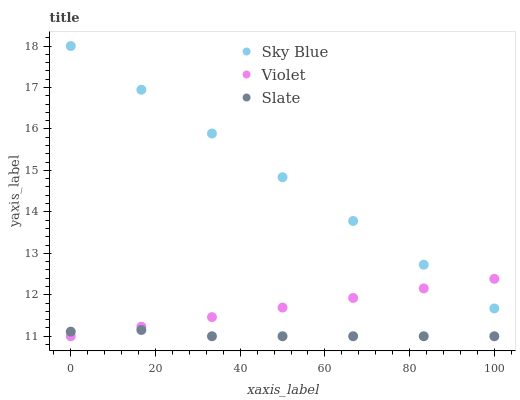Does Slate have the minimum area under the curve?
Answer yes or no. Yes. Does Sky Blue have the maximum area under the curve?
Answer yes or no. Yes. Does Violet have the minimum area under the curve?
Answer yes or no. No. Does Violet have the maximum area under the curve?
Answer yes or no. No. Is Sky Blue the smoothest?
Answer yes or no. Yes. Is Slate the roughest?
Answer yes or no. Yes. Is Violet the smoothest?
Answer yes or no. No. Is Violet the roughest?
Answer yes or no. No. Does Slate have the lowest value?
Answer yes or no. Yes. Does Sky Blue have the highest value?
Answer yes or no. Yes. Does Violet have the highest value?
Answer yes or no. No. Is Slate less than Sky Blue?
Answer yes or no. Yes. Is Sky Blue greater than Slate?
Answer yes or no. Yes. Does Sky Blue intersect Violet?
Answer yes or no. Yes. Is Sky Blue less than Violet?
Answer yes or no. No. Is Sky Blue greater than Violet?
Answer yes or no. No. Does Slate intersect Sky Blue?
Answer yes or no. No. 